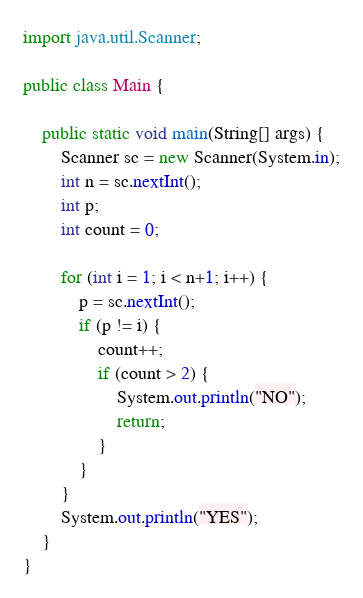Convert code to text. <code><loc_0><loc_0><loc_500><loc_500><_Java_>import java.util.Scanner;

public class Main {

	public static void main(String[] args) {
		Scanner sc = new Scanner(System.in);
		int n = sc.nextInt();
		int p;
		int count = 0;

		for (int i = 1; i < n+1; i++) {
			p = sc.nextInt();
			if (p != i) {
				count++;
				if (count > 2) {
					System.out.println("NO");
					return;
				}
			}
		}
		System.out.println("YES");
	}
}
</code> 